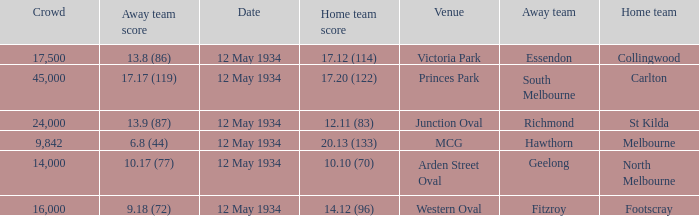What was the home teams score while playing the away team of south melbourne? 17.20 (122). 